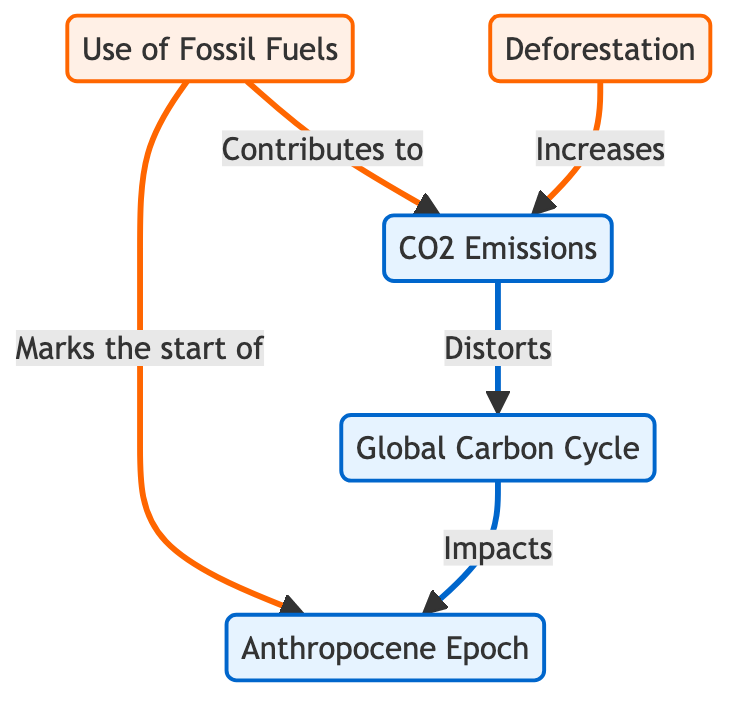What is the main process contributing to CO2 Emissions? The diagram indicates that the "Use of Fossil Fuels" is a process that directly contributes to CO2 Emissions.
Answer: Use of Fossil Fuels How many processes are depicted in the diagram? By examining the nodes, we see that "Use of Fossil Fuels" and "Deforestation" are the two processes indicated. Thus, there are 2 processes.
Answer: 2 What impact do CO2 Emissions have on the Global Carbon Cycle? According to the diagram, CO2 Emissions "Distort" the Global Carbon Cycle, indicating a negative impact.
Answer: Distorts Which epoch is marked by fossil fuel usage? The diagram states that the "Fossil Fuels" process "Marks the start of" the Anthropocene Epoch,, thus identifying the specific epoch affected.
Answer: Anthropocene Epoch How does Deforestation relate to CO2 Emissions? From the diagram, it shows that Deforestation "Increases" CO2 Emissions, establishing a direct relationship between the two.
Answer: Increases What is the relationship between the Global Carbon Cycle and the Anthropocene? The diagram demonstrates that the Global Carbon Cycle "Impacts" the Anthropocene, indicating a direct influence.
Answer: Impacts Which direction do emissions flow in relation to Fossil Fuels? The flow is directed from "Use of Fossil Fuels" to "CO2 Emissions," showing the contribution to emissions.
Answer: To CO2 Emissions What color represents the impact nodes in the diagram? The nodes that represent impact are shown in a light blue color as indicated by the class definition in the diagram.
Answer: Light blue How do CO2 Emissions influence the Carbon Cycle? The diagram states that CO2 Emissions "Distort" the Carbon Cycle, which shows a negative correlation or effect described.
Answer: Distorts 